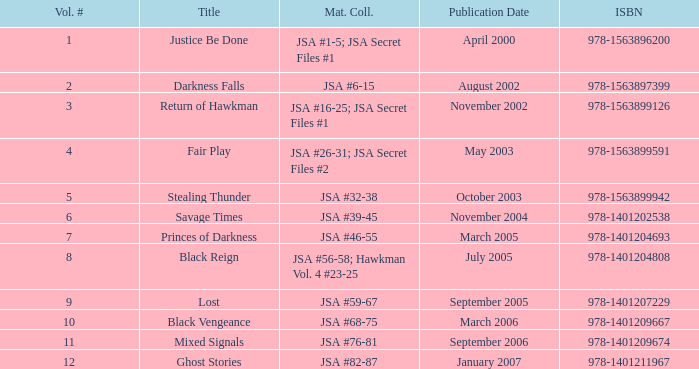What's the material compiled for the 978-1401209674 isbn? JSA #76-81. 